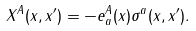Convert formula to latex. <formula><loc_0><loc_0><loc_500><loc_500>X ^ { A } ( x , x ^ { \prime } ) = - e ^ { A } _ { a } ( x ) \sigma ^ { a } ( x , x ^ { \prime } ) .</formula> 